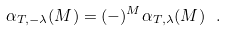<formula> <loc_0><loc_0><loc_500><loc_500>\alpha _ { T , - \lambda } ( M ) = ( - ) ^ { M } \alpha _ { T , \lambda } ( M ) \ .</formula> 